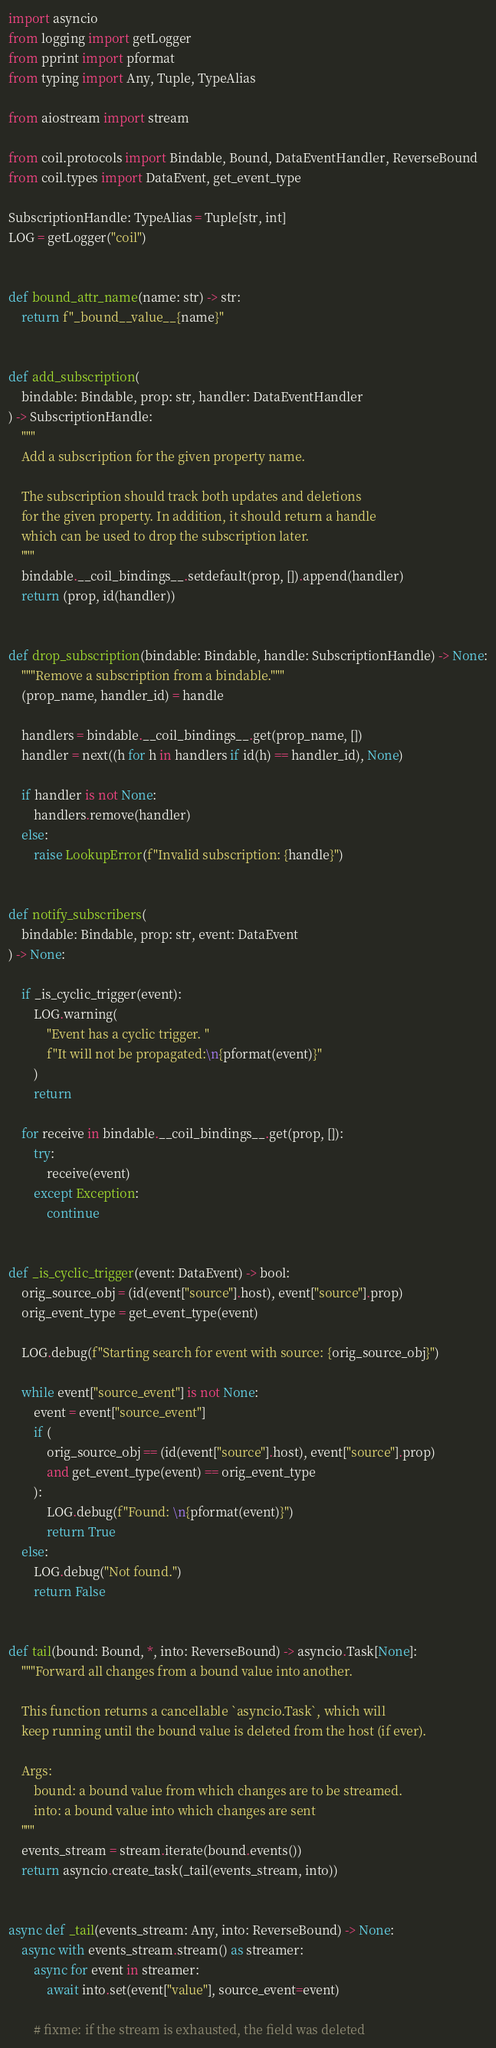Convert code to text. <code><loc_0><loc_0><loc_500><loc_500><_Python_>import asyncio
from logging import getLogger
from pprint import pformat
from typing import Any, Tuple, TypeAlias

from aiostream import stream

from coil.protocols import Bindable, Bound, DataEventHandler, ReverseBound
from coil.types import DataEvent, get_event_type

SubscriptionHandle: TypeAlias = Tuple[str, int]
LOG = getLogger("coil")


def bound_attr_name(name: str) -> str:
    return f"_bound__value__{name}"


def add_subscription(
    bindable: Bindable, prop: str, handler: DataEventHandler
) -> SubscriptionHandle:
    """
    Add a subscription for the given property name.

    The subscription should track both updates and deletions
    for the given property. In addition, it should return a handle
    which can be used to drop the subscription later.
    """
    bindable.__coil_bindings__.setdefault(prop, []).append(handler)
    return (prop, id(handler))


def drop_subscription(bindable: Bindable, handle: SubscriptionHandle) -> None:
    """Remove a subscription from a bindable."""
    (prop_name, handler_id) = handle

    handlers = bindable.__coil_bindings__.get(prop_name, [])
    handler = next((h for h in handlers if id(h) == handler_id), None)

    if handler is not None:
        handlers.remove(handler)
    else:
        raise LookupError(f"Invalid subscription: {handle}")


def notify_subscribers(
    bindable: Bindable, prop: str, event: DataEvent
) -> None:

    if _is_cyclic_trigger(event):
        LOG.warning(
            "Event has a cyclic trigger. "
            f"It will not be propagated:\n{pformat(event)}"
        )
        return

    for receive in bindable.__coil_bindings__.get(prop, []):
        try:
            receive(event)
        except Exception:
            continue


def _is_cyclic_trigger(event: DataEvent) -> bool:
    orig_source_obj = (id(event["source"].host), event["source"].prop)
    orig_event_type = get_event_type(event)

    LOG.debug(f"Starting search for event with source: {orig_source_obj}")

    while event["source_event"] is not None:
        event = event["source_event"]
        if (
            orig_source_obj == (id(event["source"].host), event["source"].prop)
            and get_event_type(event) == orig_event_type
        ):
            LOG.debug(f"Found: \n{pformat(event)}")
            return True
    else:
        LOG.debug("Not found.")
        return False


def tail(bound: Bound, *, into: ReverseBound) -> asyncio.Task[None]:
    """Forward all changes from a bound value into another.

    This function returns a cancellable `asyncio.Task`, which will
    keep running until the bound value is deleted from the host (if ever).

    Args:
        bound: a bound value from which changes are to be streamed.
        into: a bound value into which changes are sent
    """
    events_stream = stream.iterate(bound.events())
    return asyncio.create_task(_tail(events_stream, into))


async def _tail(events_stream: Any, into: ReverseBound) -> None:
    async with events_stream.stream() as streamer:
        async for event in streamer:
            await into.set(event["value"], source_event=event)

        # fixme: if the stream is exhausted, the field was deleted
</code> 